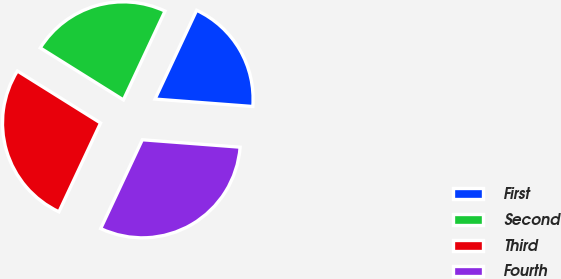Convert chart to OTSL. <chart><loc_0><loc_0><loc_500><loc_500><pie_chart><fcel>First<fcel>Second<fcel>Third<fcel>Fourth<nl><fcel>19.23%<fcel>23.08%<fcel>26.92%<fcel>30.77%<nl></chart> 